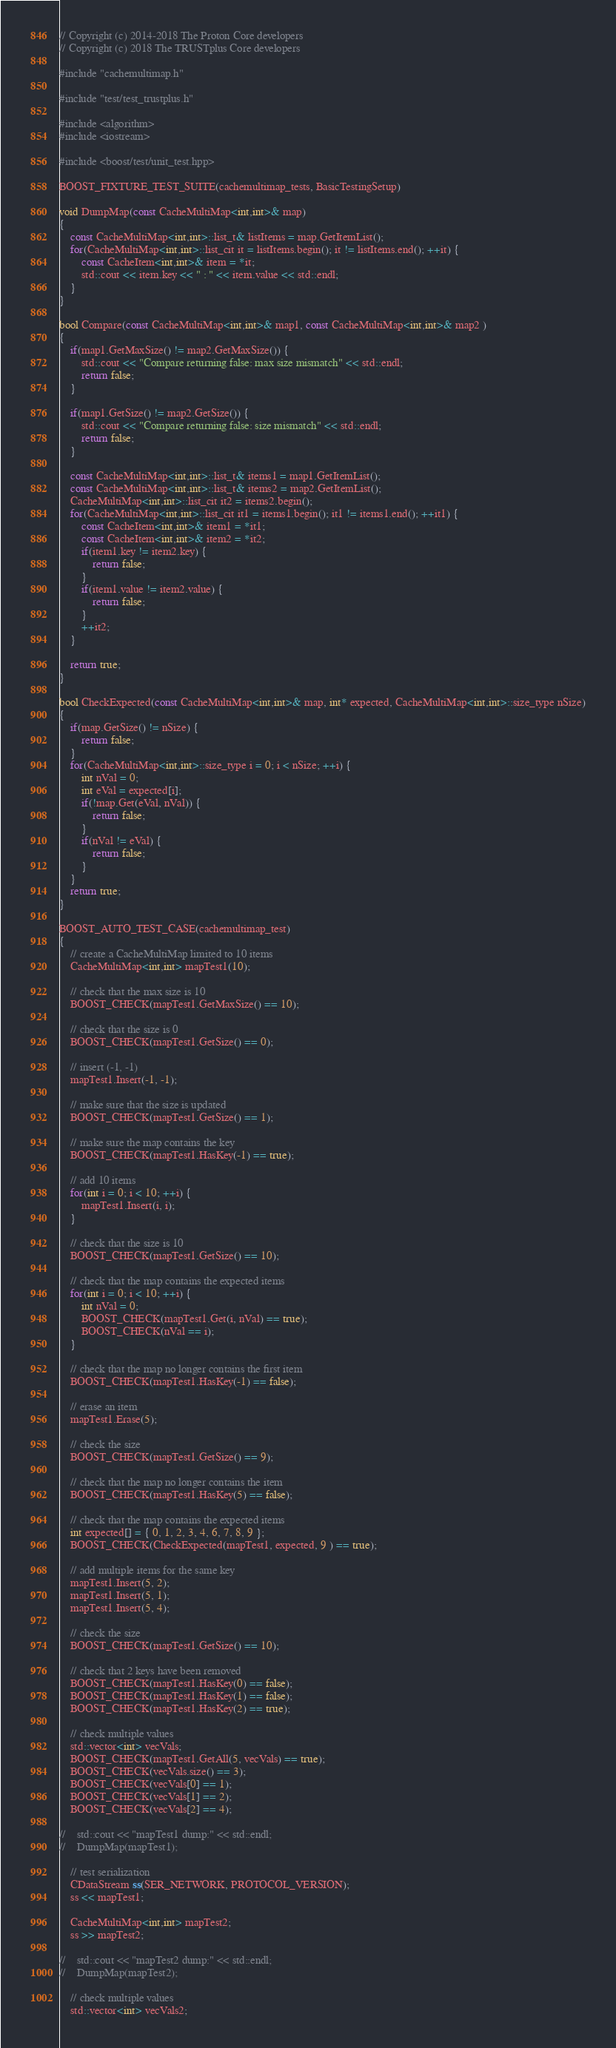<code> <loc_0><loc_0><loc_500><loc_500><_C++_>// Copyright (c) 2014-2018 The Proton Core developers
// Copyright (c) 2018 The TRUSTplus Core developers

#include "cachemultimap.h"

#include "test/test_trustplus.h"

#include <algorithm>
#include <iostream>

#include <boost/test/unit_test.hpp>

BOOST_FIXTURE_TEST_SUITE(cachemultimap_tests, BasicTestingSetup)

void DumpMap(const CacheMultiMap<int,int>& map)
{
    const CacheMultiMap<int,int>::list_t& listItems = map.GetItemList();
    for(CacheMultiMap<int,int>::list_cit it = listItems.begin(); it != listItems.end(); ++it) {
        const CacheItem<int,int>& item = *it;
        std::cout << item.key << " : " << item.value << std::endl;
    }
}

bool Compare(const CacheMultiMap<int,int>& map1, const CacheMultiMap<int,int>& map2 )
{
    if(map1.GetMaxSize() != map2.GetMaxSize()) {
        std::cout << "Compare returning false: max size mismatch" << std::endl;
        return false;
    }

    if(map1.GetSize() != map2.GetSize()) {
        std::cout << "Compare returning false: size mismatch" << std::endl;
        return false;
    }

    const CacheMultiMap<int,int>::list_t& items1 = map1.GetItemList();
    const CacheMultiMap<int,int>::list_t& items2 = map2.GetItemList();
    CacheMultiMap<int,int>::list_cit it2 = items2.begin();
    for(CacheMultiMap<int,int>::list_cit it1 = items1.begin(); it1 != items1.end(); ++it1) {
        const CacheItem<int,int>& item1 = *it1;
        const CacheItem<int,int>& item2 = *it2;
        if(item1.key != item2.key) {
            return false;
        }
        if(item1.value != item2.value) {
            return false;
        }
        ++it2;
    }

    return true;
}

bool CheckExpected(const CacheMultiMap<int,int>& map, int* expected, CacheMultiMap<int,int>::size_type nSize)
{
    if(map.GetSize() != nSize) {
        return false;
    }
    for(CacheMultiMap<int,int>::size_type i = 0; i < nSize; ++i) {
        int nVal = 0;
        int eVal = expected[i];
        if(!map.Get(eVal, nVal)) {
            return false;
        }
        if(nVal != eVal) {
            return false;
        }
    }
    return true;
}

BOOST_AUTO_TEST_CASE(cachemultimap_test)
{
    // create a CacheMultiMap limited to 10 items
    CacheMultiMap<int,int> mapTest1(10);

    // check that the max size is 10
    BOOST_CHECK(mapTest1.GetMaxSize() == 10);

    // check that the size is 0
    BOOST_CHECK(mapTest1.GetSize() == 0);

    // insert (-1, -1)
    mapTest1.Insert(-1, -1);

    // make sure that the size is updated
    BOOST_CHECK(mapTest1.GetSize() == 1);

    // make sure the map contains the key
    BOOST_CHECK(mapTest1.HasKey(-1) == true);

    // add 10 items
    for(int i = 0; i < 10; ++i) {
        mapTest1.Insert(i, i);
    }

    // check that the size is 10
    BOOST_CHECK(mapTest1.GetSize() == 10);

    // check that the map contains the expected items
    for(int i = 0; i < 10; ++i) {
        int nVal = 0;
        BOOST_CHECK(mapTest1.Get(i, nVal) == true);
        BOOST_CHECK(nVal == i);
    }

    // check that the map no longer contains the first item
    BOOST_CHECK(mapTest1.HasKey(-1) == false);

    // erase an item
    mapTest1.Erase(5);

    // check the size
    BOOST_CHECK(mapTest1.GetSize() == 9);

    // check that the map no longer contains the item
    BOOST_CHECK(mapTest1.HasKey(5) == false);

    // check that the map contains the expected items
    int expected[] = { 0, 1, 2, 3, 4, 6, 7, 8, 9 };
    BOOST_CHECK(CheckExpected(mapTest1, expected, 9 ) == true);

    // add multiple items for the same key
    mapTest1.Insert(5, 2);
    mapTest1.Insert(5, 1);
    mapTest1.Insert(5, 4);

    // check the size
    BOOST_CHECK(mapTest1.GetSize() == 10);

    // check that 2 keys have been removed
    BOOST_CHECK(mapTest1.HasKey(0) == false);
    BOOST_CHECK(mapTest1.HasKey(1) == false);
    BOOST_CHECK(mapTest1.HasKey(2) == true);

    // check multiple values
    std::vector<int> vecVals;
    BOOST_CHECK(mapTest1.GetAll(5, vecVals) == true);
    BOOST_CHECK(vecVals.size() == 3);
    BOOST_CHECK(vecVals[0] == 1);
    BOOST_CHECK(vecVals[1] == 2);
    BOOST_CHECK(vecVals[2] == 4);

//    std::cout << "mapTest1 dump:" << std::endl;
//    DumpMap(mapTest1);

    // test serialization
    CDataStream ss(SER_NETWORK, PROTOCOL_VERSION);
    ss << mapTest1;

    CacheMultiMap<int,int> mapTest2;
    ss >> mapTest2;

//    std::cout << "mapTest2 dump:" << std::endl;
//    DumpMap(mapTest2);

    // check multiple values
    std::vector<int> vecVals2;</code> 